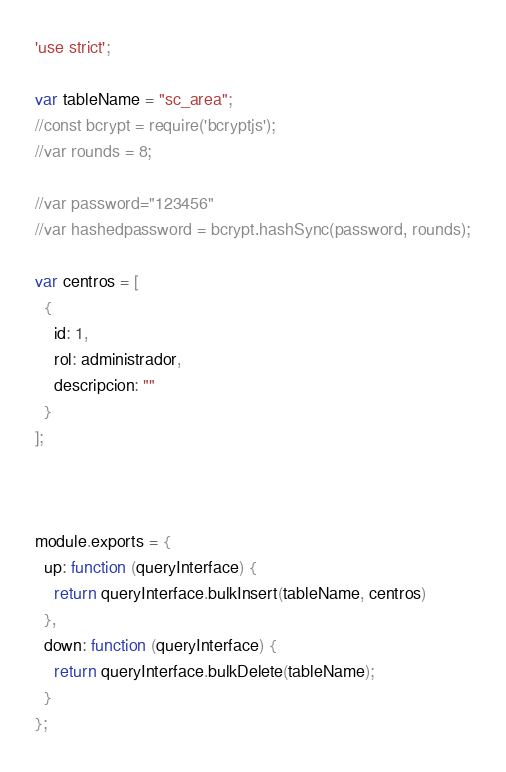<code> <loc_0><loc_0><loc_500><loc_500><_JavaScript_>'use strict';

var tableName = "sc_area";
//const bcrypt = require('bcryptjs');
//var rounds = 8;

//var password="123456"
//var hashedpassword = bcrypt.hashSync(password, rounds);

var centros = [
  {
    id: 1,
    rol: administrador,
    descripcion: ""
  }
];



module.exports = {
  up: function (queryInterface) {
    return queryInterface.bulkInsert(tableName, centros)
  },
  down: function (queryInterface) {
    return queryInterface.bulkDelete(tableName);
  }
};
</code> 